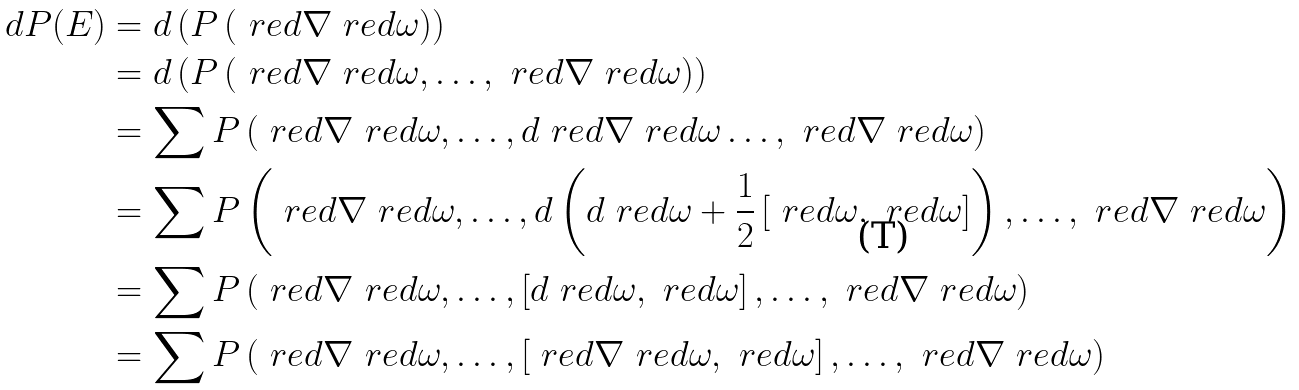Convert formula to latex. <formula><loc_0><loc_0><loc_500><loc_500>d P ( E ) & = d \left ( P \left ( \ r e d { \nabla } \ r e d { \omega } \right ) \right ) \\ & = d \left ( P \left ( \ r e d { \nabla } \ r e d { \omega } , \dots , \ r e d { \nabla } \ r e d { \omega } \right ) \right ) \\ & = \sum P \left ( \ r e d { \nabla } \ r e d { \omega } , \dots , d \ r e d { \nabla } \ r e d { \omega } \dots , \ r e d { \nabla } \ r e d { \omega } \right ) \\ & = \sum P \left ( \ r e d { \nabla } \ r e d { \omega } , \dots , d \left ( d \ r e d { \omega } + \frac { 1 } { 2 } \left [ \ r e d { \omega } , \ r e d { \omega } \right ] \right ) , \dots , \ r e d { \nabla } \ r e d { \omega } \right ) \\ & = \sum P \left ( \ r e d { \nabla } \ r e d { \omega } , \dots , \left [ d \ r e d { \omega } , \ r e d { \omega } \right ] , \dots , \ r e d { \nabla } \ r e d { \omega } \right ) \\ & = \sum P \left ( \ r e d { \nabla } \ r e d { \omega } , \dots , \left [ \ r e d { \nabla } \ r e d { \omega } , \ r e d { \omega } \right ] , \dots , \ r e d { \nabla } \ r e d { \omega } \right )</formula> 